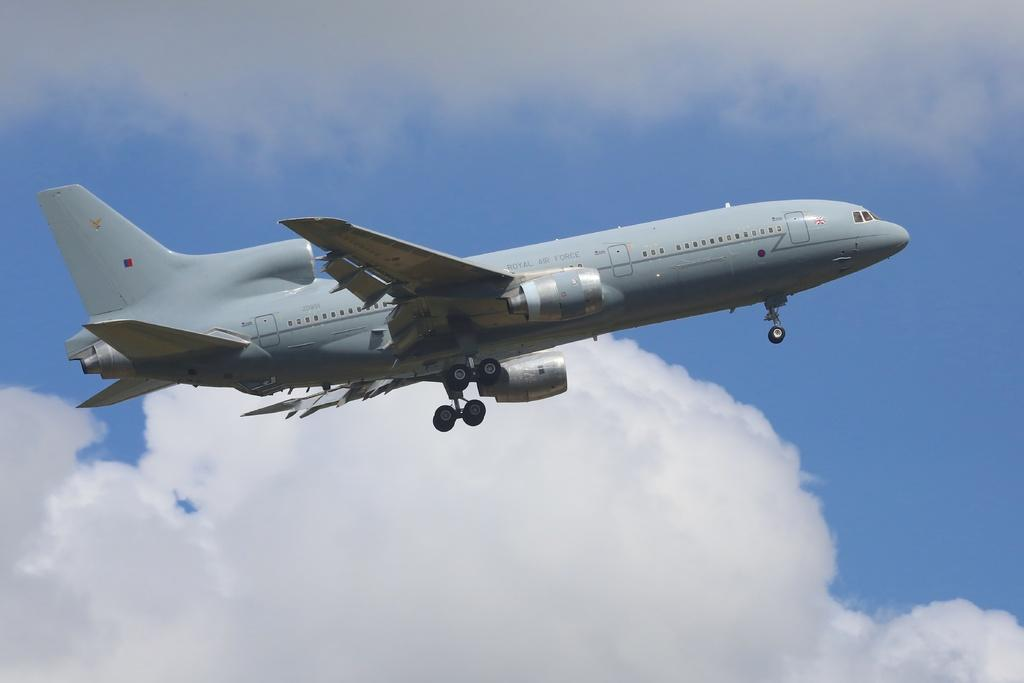What is the main subject of the image? The main subject of the image is an aeroplane. What color is the aeroplane? The aeroplane is grey in color. What else can be seen in the image besides the aeroplane? The image shows wheels. What is the color of the sky in the image? The sky is blue and white in color. Can you see a boot hanging from the aeroplane in the image? No, there is no boot visible in the image. How many twigs are present in the image? There are no twigs present in the image; it features an aeroplane, wheels, and a blue and white sky. 